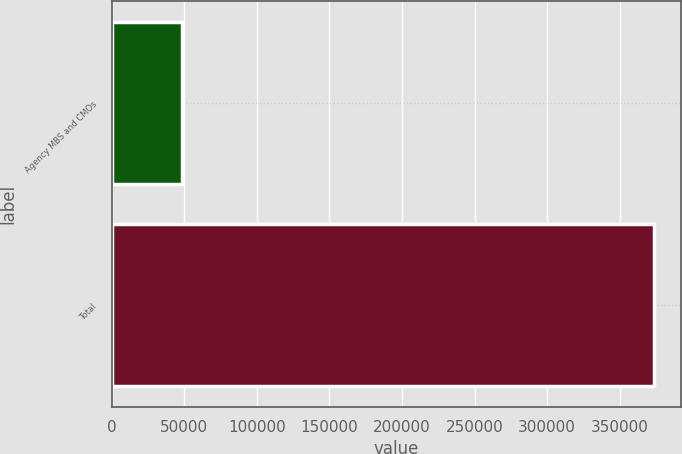Convert chart to OTSL. <chart><loc_0><loc_0><loc_500><loc_500><bar_chart><fcel>Agency MBS and CMOs<fcel>Total<nl><fcel>48154<fcel>373486<nl></chart> 